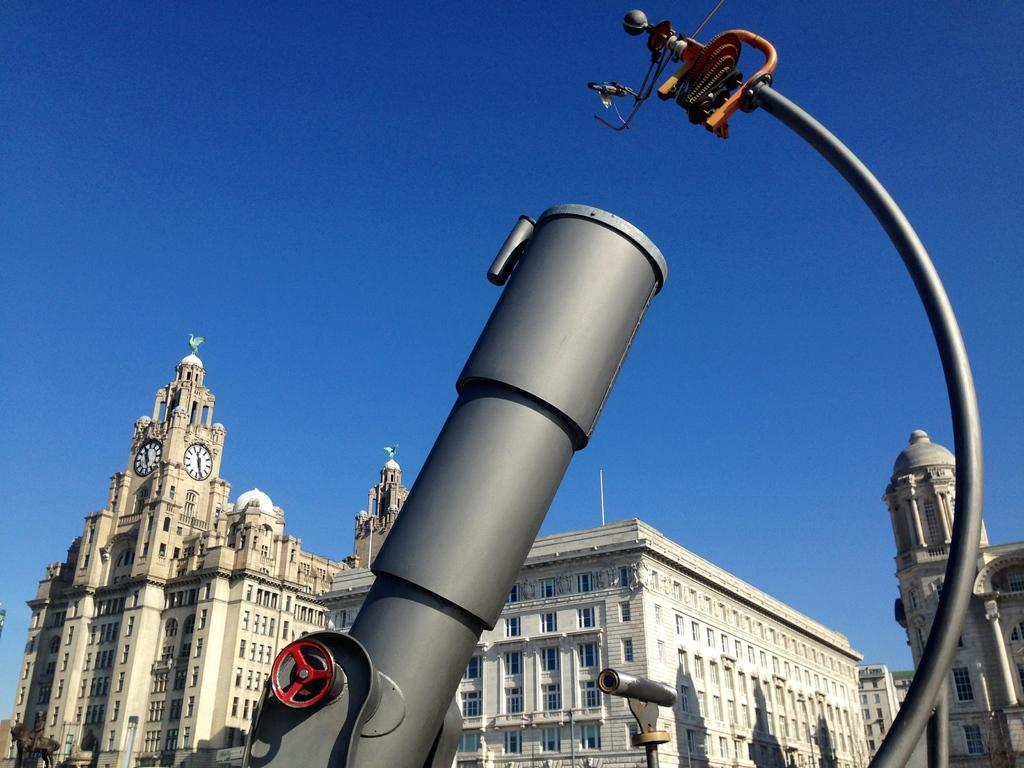What type of structures can be seen in the image? There are buildings in the image. What architectural features are visible on the buildings? There are windows visible on the buildings. What additional object can be seen in the image? There is a statue in the image. What is attached to the wall in the image? There are blocks attached to a wall in the image. What color is the ash-colored object in the image? The ash-colored object in the image is, well, ash-colored. What is visible in the background of the image? The sky is visible in the image. Can you tell me how many cables are connected to the statue in the image? There are no cables connected to the statue in the image. What type of ring is visible on the statue's finger in the image? There is no ring visible on the statue's finger in the image. 